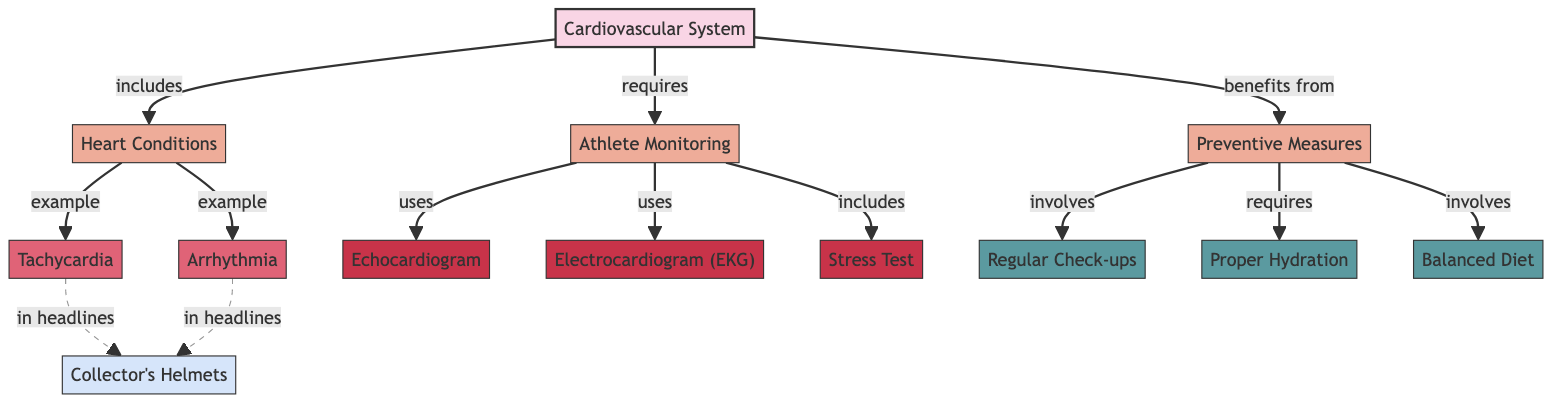What are the two examples of heart conditions listed in the diagram? The diagram specifies "Tachycardia" and "Arrhythmia" as examples of heart conditions within the shaded area representing heart conditions.
Answer: Tachycardia, Arrhythmia How many types of instruments are used in athlete monitoring? The diagram shows three instruments: "Echocardiogram," "Electrocardiogram (EKG)," and "Stress Test," which are categorized under athlete monitoring. By counting these nodes, we find there are three.
Answer: 3 Which preventive measure requires proper hydration? The diagram explicitly states that proper hydration is a requirement listed under preventive measures, linking it directly to the need for a healthy cardiovascular system.
Answer: Proper Hydration What directly benefits from preventive measures? The flow from the preventive measures node connects to the cardiovascular system node, indicating that the cardiovascular system benefits directly from the measures outlined.
Answer: Cardiovascular System What connections are dashed in the diagram? The dashed connections in the diagram link the heart conditions "Tachycardia" and "Arrhythmia" to "Collector's Helmets" indicating an indirect relationship or significance in headlines rather than direct attributes.
Answer: Tachycardia, Arrhythmia What is involved in preventive measures? The diagram lists two items explicitly involved in preventive measures: "Regular Check-ups" and "Balanced Diet." These are distinct nodes that are crucial for maintaining cardiovascular health.
Answer: Regular Check-ups, Balanced Diet How many heart conditions are mentioned in the diagram? The diagram specifically mentions two heart conditions, "Tachycardia" and "Arrhythmia." By identifying these nodes under the heart conditions section, we conclude there are two.
Answer: 2 Which instrument is used alongside the EKG in athlete monitoring? The diagram shows both "Echocardiogram" and "Stress Test" as instruments used in athlete monitoring, indicating that EKG is used with at least one of these two.
Answer: Echocardiogram, Stress Test What is identified as a special item related to heart conditions? The diagram connects both heart conditions "Tachycardia" and "Arrhythmia" to "Collector's Helmets," illustrating a unique categorization that stands out.
Answer: Collector's Helmets 